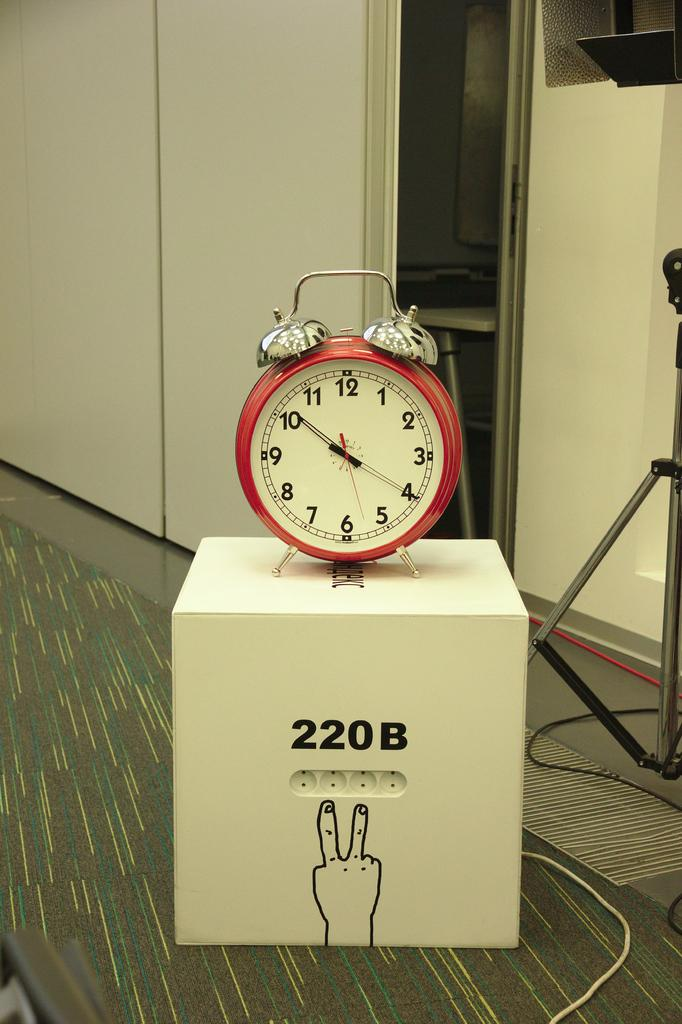<image>
Offer a succinct explanation of the picture presented. A large red alarm clock sits on a cube that says 220B. 